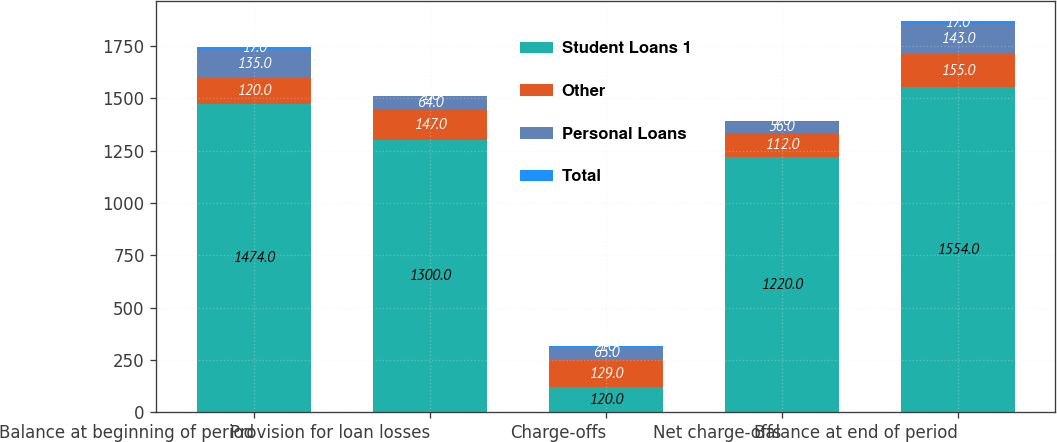Convert chart to OTSL. <chart><loc_0><loc_0><loc_500><loc_500><stacked_bar_chart><ecel><fcel>Balance at beginning of period<fcel>Provision for loan losses<fcel>Charge-offs<fcel>Net charge-offs<fcel>Balance at end of period<nl><fcel>Student Loans 1<fcel>1474<fcel>1300<fcel>120<fcel>1220<fcel>1554<nl><fcel>Other<fcel>120<fcel>147<fcel>129<fcel>112<fcel>155<nl><fcel>Personal Loans<fcel>135<fcel>64<fcel>65<fcel>56<fcel>143<nl><fcel>Total<fcel>17<fcel>1<fcel>1<fcel>1<fcel>17<nl></chart> 